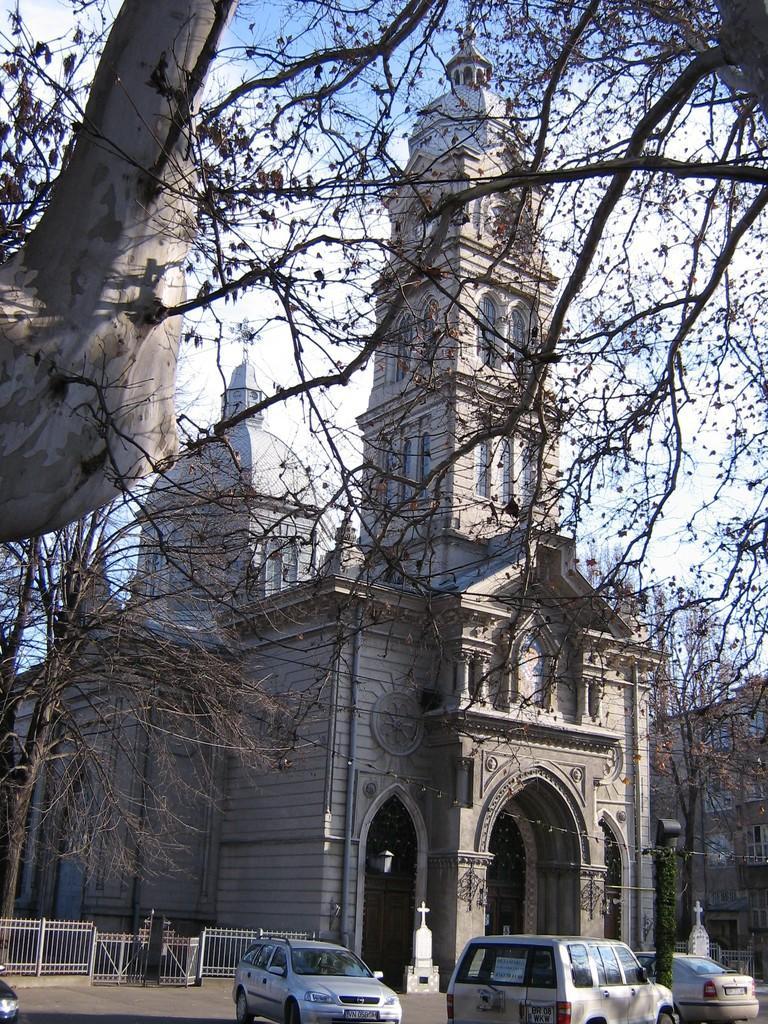Could you give a brief overview of what you see in this image? In this picture there is a building and there are vehicles on the road and there are trees. On the left side of the image there is a railing. At the top there is sky and there are clouds. At the bottom there is a road. 